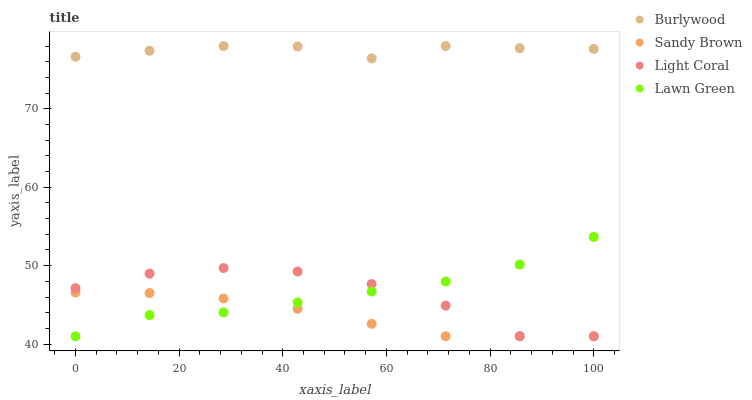Does Sandy Brown have the minimum area under the curve?
Answer yes or no. Yes. Does Burlywood have the maximum area under the curve?
Answer yes or no. Yes. Does Light Coral have the minimum area under the curve?
Answer yes or no. No. Does Light Coral have the maximum area under the curve?
Answer yes or no. No. Is Sandy Brown the smoothest?
Answer yes or no. Yes. Is Light Coral the roughest?
Answer yes or no. Yes. Is Light Coral the smoothest?
Answer yes or no. No. Is Sandy Brown the roughest?
Answer yes or no. No. Does Light Coral have the lowest value?
Answer yes or no. Yes. Does Burlywood have the highest value?
Answer yes or no. Yes. Does Light Coral have the highest value?
Answer yes or no. No. Is Lawn Green less than Burlywood?
Answer yes or no. Yes. Is Burlywood greater than Lawn Green?
Answer yes or no. Yes. Does Light Coral intersect Sandy Brown?
Answer yes or no. Yes. Is Light Coral less than Sandy Brown?
Answer yes or no. No. Is Light Coral greater than Sandy Brown?
Answer yes or no. No. Does Lawn Green intersect Burlywood?
Answer yes or no. No. 